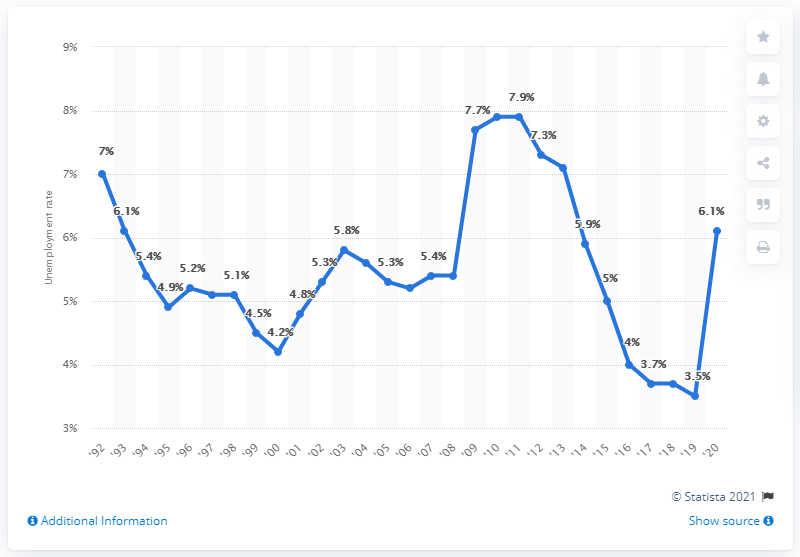List a handful of essential elements in this visual. In 2020, the unemployment rate in Arkansas was 6.1%. 